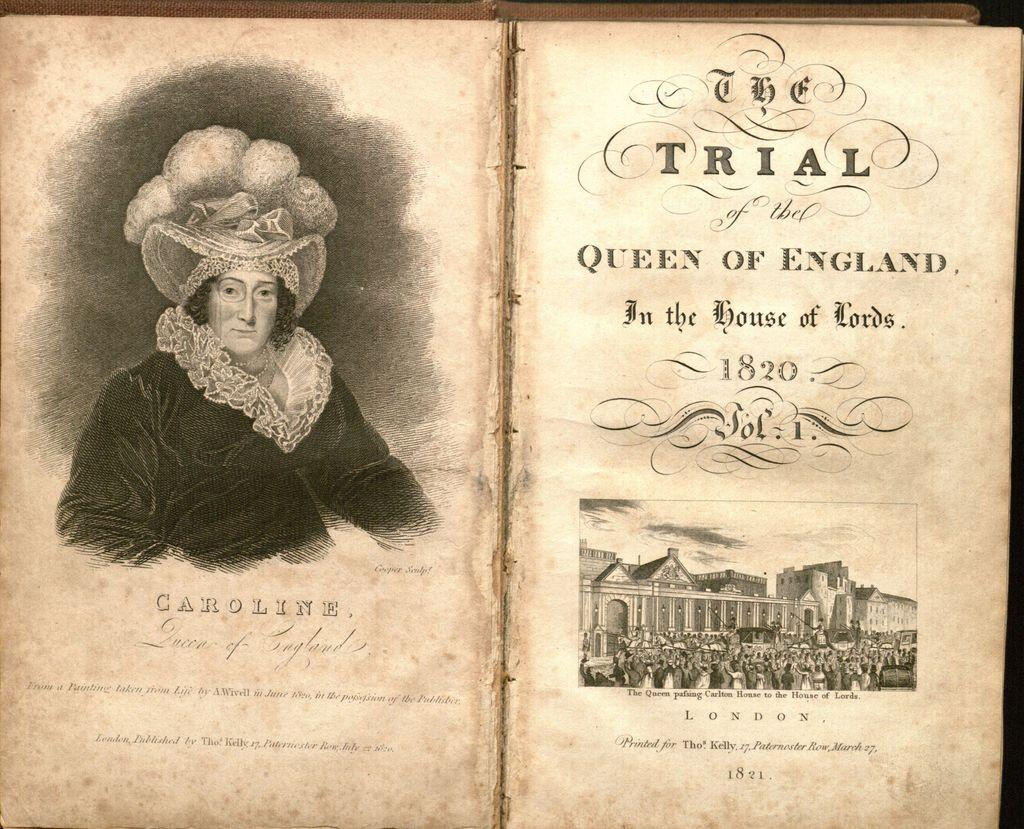<image>
Write a terse but informative summary of the picture. A book is open with a picture of Caroline on the left. 